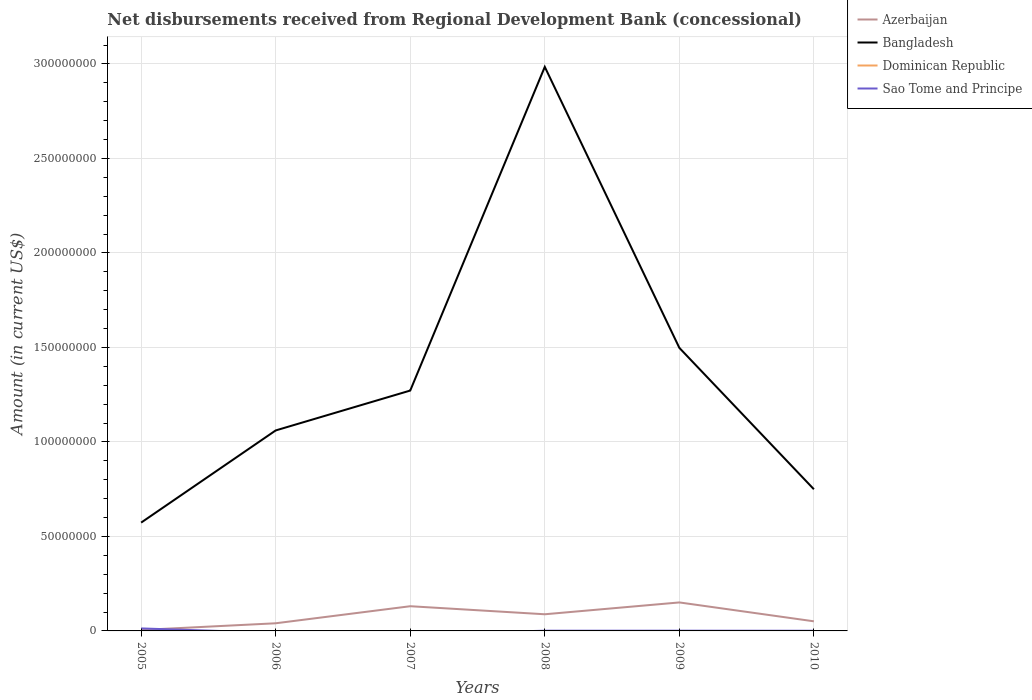Does the line corresponding to Dominican Republic intersect with the line corresponding to Azerbaijan?
Offer a very short reply. No. Is the number of lines equal to the number of legend labels?
Provide a short and direct response. No. What is the total amount of disbursements received from Regional Development Bank in Bangladesh in the graph?
Offer a terse response. -2.26e+07. What is the difference between the highest and the second highest amount of disbursements received from Regional Development Bank in Bangladesh?
Keep it short and to the point. 2.41e+08. What is the difference between the highest and the lowest amount of disbursements received from Regional Development Bank in Sao Tome and Principe?
Offer a terse response. 1. How many lines are there?
Your answer should be compact. 3. How many years are there in the graph?
Make the answer very short. 6. Are the values on the major ticks of Y-axis written in scientific E-notation?
Your answer should be very brief. No. Where does the legend appear in the graph?
Make the answer very short. Top right. How many legend labels are there?
Provide a succinct answer. 4. How are the legend labels stacked?
Give a very brief answer. Vertical. What is the title of the graph?
Make the answer very short. Net disbursements received from Regional Development Bank (concessional). Does "Singapore" appear as one of the legend labels in the graph?
Offer a very short reply. No. What is the label or title of the X-axis?
Your answer should be very brief. Years. What is the Amount (in current US$) in Azerbaijan in 2005?
Your answer should be very brief. 5.03e+05. What is the Amount (in current US$) in Bangladesh in 2005?
Your response must be concise. 5.73e+07. What is the Amount (in current US$) of Dominican Republic in 2005?
Ensure brevity in your answer.  0. What is the Amount (in current US$) of Sao Tome and Principe in 2005?
Provide a short and direct response. 1.32e+06. What is the Amount (in current US$) of Azerbaijan in 2006?
Provide a short and direct response. 4.04e+06. What is the Amount (in current US$) of Bangladesh in 2006?
Keep it short and to the point. 1.06e+08. What is the Amount (in current US$) of Dominican Republic in 2006?
Offer a terse response. 0. What is the Amount (in current US$) of Sao Tome and Principe in 2006?
Ensure brevity in your answer.  0. What is the Amount (in current US$) in Azerbaijan in 2007?
Give a very brief answer. 1.31e+07. What is the Amount (in current US$) of Bangladesh in 2007?
Provide a short and direct response. 1.27e+08. What is the Amount (in current US$) in Dominican Republic in 2007?
Keep it short and to the point. 0. What is the Amount (in current US$) in Azerbaijan in 2008?
Keep it short and to the point. 8.81e+06. What is the Amount (in current US$) of Bangladesh in 2008?
Your answer should be very brief. 2.98e+08. What is the Amount (in current US$) in Dominican Republic in 2008?
Your answer should be very brief. 0. What is the Amount (in current US$) in Sao Tome and Principe in 2008?
Provide a succinct answer. 1.18e+05. What is the Amount (in current US$) of Azerbaijan in 2009?
Ensure brevity in your answer.  1.51e+07. What is the Amount (in current US$) in Bangladesh in 2009?
Keep it short and to the point. 1.50e+08. What is the Amount (in current US$) in Dominican Republic in 2009?
Offer a terse response. 0. What is the Amount (in current US$) in Sao Tome and Principe in 2009?
Give a very brief answer. 1.20e+05. What is the Amount (in current US$) of Azerbaijan in 2010?
Make the answer very short. 5.08e+06. What is the Amount (in current US$) of Bangladesh in 2010?
Your answer should be very brief. 7.50e+07. What is the Amount (in current US$) in Dominican Republic in 2010?
Make the answer very short. 0. What is the Amount (in current US$) in Sao Tome and Principe in 2010?
Keep it short and to the point. 9.30e+04. Across all years, what is the maximum Amount (in current US$) of Azerbaijan?
Your answer should be very brief. 1.51e+07. Across all years, what is the maximum Amount (in current US$) of Bangladesh?
Ensure brevity in your answer.  2.98e+08. Across all years, what is the maximum Amount (in current US$) of Sao Tome and Principe?
Ensure brevity in your answer.  1.32e+06. Across all years, what is the minimum Amount (in current US$) in Azerbaijan?
Provide a short and direct response. 5.03e+05. Across all years, what is the minimum Amount (in current US$) of Bangladesh?
Provide a succinct answer. 5.73e+07. Across all years, what is the minimum Amount (in current US$) in Sao Tome and Principe?
Provide a short and direct response. 0. What is the total Amount (in current US$) of Azerbaijan in the graph?
Make the answer very short. 4.66e+07. What is the total Amount (in current US$) of Bangladesh in the graph?
Offer a very short reply. 8.14e+08. What is the total Amount (in current US$) of Sao Tome and Principe in the graph?
Keep it short and to the point. 1.65e+06. What is the difference between the Amount (in current US$) of Azerbaijan in 2005 and that in 2006?
Your response must be concise. -3.54e+06. What is the difference between the Amount (in current US$) of Bangladesh in 2005 and that in 2006?
Ensure brevity in your answer.  -4.88e+07. What is the difference between the Amount (in current US$) in Azerbaijan in 2005 and that in 2007?
Give a very brief answer. -1.26e+07. What is the difference between the Amount (in current US$) in Bangladesh in 2005 and that in 2007?
Your response must be concise. -6.99e+07. What is the difference between the Amount (in current US$) in Azerbaijan in 2005 and that in 2008?
Offer a terse response. -8.31e+06. What is the difference between the Amount (in current US$) in Bangladesh in 2005 and that in 2008?
Ensure brevity in your answer.  -2.41e+08. What is the difference between the Amount (in current US$) in Sao Tome and Principe in 2005 and that in 2008?
Make the answer very short. 1.20e+06. What is the difference between the Amount (in current US$) of Azerbaijan in 2005 and that in 2009?
Make the answer very short. -1.46e+07. What is the difference between the Amount (in current US$) in Bangladesh in 2005 and that in 2009?
Give a very brief answer. -9.25e+07. What is the difference between the Amount (in current US$) of Sao Tome and Principe in 2005 and that in 2009?
Keep it short and to the point. 1.20e+06. What is the difference between the Amount (in current US$) of Azerbaijan in 2005 and that in 2010?
Your answer should be compact. -4.58e+06. What is the difference between the Amount (in current US$) of Bangladesh in 2005 and that in 2010?
Offer a terse response. -1.76e+07. What is the difference between the Amount (in current US$) in Sao Tome and Principe in 2005 and that in 2010?
Make the answer very short. 1.23e+06. What is the difference between the Amount (in current US$) in Azerbaijan in 2006 and that in 2007?
Make the answer very short. -9.02e+06. What is the difference between the Amount (in current US$) of Bangladesh in 2006 and that in 2007?
Your answer should be compact. -2.11e+07. What is the difference between the Amount (in current US$) of Azerbaijan in 2006 and that in 2008?
Give a very brief answer. -4.77e+06. What is the difference between the Amount (in current US$) of Bangladesh in 2006 and that in 2008?
Your answer should be very brief. -1.92e+08. What is the difference between the Amount (in current US$) in Azerbaijan in 2006 and that in 2009?
Your answer should be compact. -1.10e+07. What is the difference between the Amount (in current US$) in Bangladesh in 2006 and that in 2009?
Your answer should be very brief. -4.37e+07. What is the difference between the Amount (in current US$) in Azerbaijan in 2006 and that in 2010?
Give a very brief answer. -1.04e+06. What is the difference between the Amount (in current US$) of Bangladesh in 2006 and that in 2010?
Offer a very short reply. 3.11e+07. What is the difference between the Amount (in current US$) of Azerbaijan in 2007 and that in 2008?
Provide a short and direct response. 4.26e+06. What is the difference between the Amount (in current US$) of Bangladesh in 2007 and that in 2008?
Offer a very short reply. -1.71e+08. What is the difference between the Amount (in current US$) in Azerbaijan in 2007 and that in 2009?
Keep it short and to the point. -2.00e+06. What is the difference between the Amount (in current US$) of Bangladesh in 2007 and that in 2009?
Your answer should be compact. -2.26e+07. What is the difference between the Amount (in current US$) in Azerbaijan in 2007 and that in 2010?
Offer a very short reply. 7.98e+06. What is the difference between the Amount (in current US$) of Bangladesh in 2007 and that in 2010?
Your answer should be compact. 5.22e+07. What is the difference between the Amount (in current US$) of Azerbaijan in 2008 and that in 2009?
Keep it short and to the point. -6.26e+06. What is the difference between the Amount (in current US$) of Bangladesh in 2008 and that in 2009?
Make the answer very short. 1.49e+08. What is the difference between the Amount (in current US$) in Sao Tome and Principe in 2008 and that in 2009?
Your answer should be compact. -2000. What is the difference between the Amount (in current US$) in Azerbaijan in 2008 and that in 2010?
Your response must be concise. 3.73e+06. What is the difference between the Amount (in current US$) in Bangladesh in 2008 and that in 2010?
Provide a short and direct response. 2.24e+08. What is the difference between the Amount (in current US$) of Sao Tome and Principe in 2008 and that in 2010?
Your response must be concise. 2.50e+04. What is the difference between the Amount (in current US$) in Azerbaijan in 2009 and that in 2010?
Ensure brevity in your answer.  9.99e+06. What is the difference between the Amount (in current US$) in Bangladesh in 2009 and that in 2010?
Give a very brief answer. 7.48e+07. What is the difference between the Amount (in current US$) of Sao Tome and Principe in 2009 and that in 2010?
Give a very brief answer. 2.70e+04. What is the difference between the Amount (in current US$) of Azerbaijan in 2005 and the Amount (in current US$) of Bangladesh in 2006?
Your response must be concise. -1.06e+08. What is the difference between the Amount (in current US$) of Azerbaijan in 2005 and the Amount (in current US$) of Bangladesh in 2007?
Make the answer very short. -1.27e+08. What is the difference between the Amount (in current US$) of Azerbaijan in 2005 and the Amount (in current US$) of Bangladesh in 2008?
Provide a succinct answer. -2.98e+08. What is the difference between the Amount (in current US$) in Azerbaijan in 2005 and the Amount (in current US$) in Sao Tome and Principe in 2008?
Offer a terse response. 3.85e+05. What is the difference between the Amount (in current US$) of Bangladesh in 2005 and the Amount (in current US$) of Sao Tome and Principe in 2008?
Give a very brief answer. 5.72e+07. What is the difference between the Amount (in current US$) of Azerbaijan in 2005 and the Amount (in current US$) of Bangladesh in 2009?
Provide a succinct answer. -1.49e+08. What is the difference between the Amount (in current US$) of Azerbaijan in 2005 and the Amount (in current US$) of Sao Tome and Principe in 2009?
Give a very brief answer. 3.83e+05. What is the difference between the Amount (in current US$) of Bangladesh in 2005 and the Amount (in current US$) of Sao Tome and Principe in 2009?
Provide a short and direct response. 5.72e+07. What is the difference between the Amount (in current US$) of Azerbaijan in 2005 and the Amount (in current US$) of Bangladesh in 2010?
Offer a terse response. -7.45e+07. What is the difference between the Amount (in current US$) in Azerbaijan in 2005 and the Amount (in current US$) in Sao Tome and Principe in 2010?
Ensure brevity in your answer.  4.10e+05. What is the difference between the Amount (in current US$) in Bangladesh in 2005 and the Amount (in current US$) in Sao Tome and Principe in 2010?
Your response must be concise. 5.72e+07. What is the difference between the Amount (in current US$) in Azerbaijan in 2006 and the Amount (in current US$) in Bangladesh in 2007?
Offer a very short reply. -1.23e+08. What is the difference between the Amount (in current US$) of Azerbaijan in 2006 and the Amount (in current US$) of Bangladesh in 2008?
Ensure brevity in your answer.  -2.94e+08. What is the difference between the Amount (in current US$) in Azerbaijan in 2006 and the Amount (in current US$) in Sao Tome and Principe in 2008?
Ensure brevity in your answer.  3.93e+06. What is the difference between the Amount (in current US$) of Bangladesh in 2006 and the Amount (in current US$) of Sao Tome and Principe in 2008?
Ensure brevity in your answer.  1.06e+08. What is the difference between the Amount (in current US$) in Azerbaijan in 2006 and the Amount (in current US$) in Bangladesh in 2009?
Your answer should be very brief. -1.46e+08. What is the difference between the Amount (in current US$) in Azerbaijan in 2006 and the Amount (in current US$) in Sao Tome and Principe in 2009?
Provide a short and direct response. 3.92e+06. What is the difference between the Amount (in current US$) of Bangladesh in 2006 and the Amount (in current US$) of Sao Tome and Principe in 2009?
Ensure brevity in your answer.  1.06e+08. What is the difference between the Amount (in current US$) in Azerbaijan in 2006 and the Amount (in current US$) in Bangladesh in 2010?
Provide a short and direct response. -7.09e+07. What is the difference between the Amount (in current US$) of Azerbaijan in 2006 and the Amount (in current US$) of Sao Tome and Principe in 2010?
Offer a very short reply. 3.95e+06. What is the difference between the Amount (in current US$) in Bangladesh in 2006 and the Amount (in current US$) in Sao Tome and Principe in 2010?
Make the answer very short. 1.06e+08. What is the difference between the Amount (in current US$) in Azerbaijan in 2007 and the Amount (in current US$) in Bangladesh in 2008?
Your answer should be compact. -2.85e+08. What is the difference between the Amount (in current US$) of Azerbaijan in 2007 and the Amount (in current US$) of Sao Tome and Principe in 2008?
Provide a succinct answer. 1.30e+07. What is the difference between the Amount (in current US$) of Bangladesh in 2007 and the Amount (in current US$) of Sao Tome and Principe in 2008?
Offer a very short reply. 1.27e+08. What is the difference between the Amount (in current US$) in Azerbaijan in 2007 and the Amount (in current US$) in Bangladesh in 2009?
Provide a short and direct response. -1.37e+08. What is the difference between the Amount (in current US$) of Azerbaijan in 2007 and the Amount (in current US$) of Sao Tome and Principe in 2009?
Your answer should be very brief. 1.30e+07. What is the difference between the Amount (in current US$) of Bangladesh in 2007 and the Amount (in current US$) of Sao Tome and Principe in 2009?
Provide a short and direct response. 1.27e+08. What is the difference between the Amount (in current US$) of Azerbaijan in 2007 and the Amount (in current US$) of Bangladesh in 2010?
Your response must be concise. -6.19e+07. What is the difference between the Amount (in current US$) of Azerbaijan in 2007 and the Amount (in current US$) of Sao Tome and Principe in 2010?
Ensure brevity in your answer.  1.30e+07. What is the difference between the Amount (in current US$) in Bangladesh in 2007 and the Amount (in current US$) in Sao Tome and Principe in 2010?
Provide a short and direct response. 1.27e+08. What is the difference between the Amount (in current US$) of Azerbaijan in 2008 and the Amount (in current US$) of Bangladesh in 2009?
Provide a succinct answer. -1.41e+08. What is the difference between the Amount (in current US$) in Azerbaijan in 2008 and the Amount (in current US$) in Sao Tome and Principe in 2009?
Provide a succinct answer. 8.69e+06. What is the difference between the Amount (in current US$) of Bangladesh in 2008 and the Amount (in current US$) of Sao Tome and Principe in 2009?
Your answer should be very brief. 2.98e+08. What is the difference between the Amount (in current US$) of Azerbaijan in 2008 and the Amount (in current US$) of Bangladesh in 2010?
Your answer should be compact. -6.62e+07. What is the difference between the Amount (in current US$) of Azerbaijan in 2008 and the Amount (in current US$) of Sao Tome and Principe in 2010?
Keep it short and to the point. 8.72e+06. What is the difference between the Amount (in current US$) of Bangladesh in 2008 and the Amount (in current US$) of Sao Tome and Principe in 2010?
Provide a short and direct response. 2.98e+08. What is the difference between the Amount (in current US$) of Azerbaijan in 2009 and the Amount (in current US$) of Bangladesh in 2010?
Your answer should be compact. -5.99e+07. What is the difference between the Amount (in current US$) in Azerbaijan in 2009 and the Amount (in current US$) in Sao Tome and Principe in 2010?
Give a very brief answer. 1.50e+07. What is the difference between the Amount (in current US$) of Bangladesh in 2009 and the Amount (in current US$) of Sao Tome and Principe in 2010?
Give a very brief answer. 1.50e+08. What is the average Amount (in current US$) in Azerbaijan per year?
Offer a terse response. 7.77e+06. What is the average Amount (in current US$) of Bangladesh per year?
Offer a very short reply. 1.36e+08. What is the average Amount (in current US$) in Sao Tome and Principe per year?
Offer a very short reply. 2.75e+05. In the year 2005, what is the difference between the Amount (in current US$) of Azerbaijan and Amount (in current US$) of Bangladesh?
Ensure brevity in your answer.  -5.68e+07. In the year 2005, what is the difference between the Amount (in current US$) of Azerbaijan and Amount (in current US$) of Sao Tome and Principe?
Your answer should be compact. -8.18e+05. In the year 2005, what is the difference between the Amount (in current US$) in Bangladesh and Amount (in current US$) in Sao Tome and Principe?
Provide a succinct answer. 5.60e+07. In the year 2006, what is the difference between the Amount (in current US$) in Azerbaijan and Amount (in current US$) in Bangladesh?
Make the answer very short. -1.02e+08. In the year 2007, what is the difference between the Amount (in current US$) of Azerbaijan and Amount (in current US$) of Bangladesh?
Ensure brevity in your answer.  -1.14e+08. In the year 2008, what is the difference between the Amount (in current US$) in Azerbaijan and Amount (in current US$) in Bangladesh?
Keep it short and to the point. -2.90e+08. In the year 2008, what is the difference between the Amount (in current US$) in Azerbaijan and Amount (in current US$) in Sao Tome and Principe?
Ensure brevity in your answer.  8.70e+06. In the year 2008, what is the difference between the Amount (in current US$) in Bangladesh and Amount (in current US$) in Sao Tome and Principe?
Your answer should be compact. 2.98e+08. In the year 2009, what is the difference between the Amount (in current US$) in Azerbaijan and Amount (in current US$) in Bangladesh?
Offer a very short reply. -1.35e+08. In the year 2009, what is the difference between the Amount (in current US$) of Azerbaijan and Amount (in current US$) of Sao Tome and Principe?
Your response must be concise. 1.50e+07. In the year 2009, what is the difference between the Amount (in current US$) of Bangladesh and Amount (in current US$) of Sao Tome and Principe?
Your response must be concise. 1.50e+08. In the year 2010, what is the difference between the Amount (in current US$) in Azerbaijan and Amount (in current US$) in Bangladesh?
Ensure brevity in your answer.  -6.99e+07. In the year 2010, what is the difference between the Amount (in current US$) in Azerbaijan and Amount (in current US$) in Sao Tome and Principe?
Provide a succinct answer. 4.99e+06. In the year 2010, what is the difference between the Amount (in current US$) of Bangladesh and Amount (in current US$) of Sao Tome and Principe?
Offer a very short reply. 7.49e+07. What is the ratio of the Amount (in current US$) of Azerbaijan in 2005 to that in 2006?
Offer a very short reply. 0.12. What is the ratio of the Amount (in current US$) in Bangladesh in 2005 to that in 2006?
Offer a very short reply. 0.54. What is the ratio of the Amount (in current US$) of Azerbaijan in 2005 to that in 2007?
Ensure brevity in your answer.  0.04. What is the ratio of the Amount (in current US$) of Bangladesh in 2005 to that in 2007?
Keep it short and to the point. 0.45. What is the ratio of the Amount (in current US$) of Azerbaijan in 2005 to that in 2008?
Your answer should be compact. 0.06. What is the ratio of the Amount (in current US$) of Bangladesh in 2005 to that in 2008?
Keep it short and to the point. 0.19. What is the ratio of the Amount (in current US$) of Sao Tome and Principe in 2005 to that in 2008?
Provide a short and direct response. 11.19. What is the ratio of the Amount (in current US$) of Azerbaijan in 2005 to that in 2009?
Provide a short and direct response. 0.03. What is the ratio of the Amount (in current US$) in Bangladesh in 2005 to that in 2009?
Provide a succinct answer. 0.38. What is the ratio of the Amount (in current US$) of Sao Tome and Principe in 2005 to that in 2009?
Offer a terse response. 11.01. What is the ratio of the Amount (in current US$) of Azerbaijan in 2005 to that in 2010?
Give a very brief answer. 0.1. What is the ratio of the Amount (in current US$) in Bangladesh in 2005 to that in 2010?
Provide a short and direct response. 0.76. What is the ratio of the Amount (in current US$) in Sao Tome and Principe in 2005 to that in 2010?
Ensure brevity in your answer.  14.2. What is the ratio of the Amount (in current US$) in Azerbaijan in 2006 to that in 2007?
Offer a very short reply. 0.31. What is the ratio of the Amount (in current US$) of Bangladesh in 2006 to that in 2007?
Your answer should be very brief. 0.83. What is the ratio of the Amount (in current US$) in Azerbaijan in 2006 to that in 2008?
Provide a succinct answer. 0.46. What is the ratio of the Amount (in current US$) of Bangladesh in 2006 to that in 2008?
Provide a short and direct response. 0.36. What is the ratio of the Amount (in current US$) of Azerbaijan in 2006 to that in 2009?
Ensure brevity in your answer.  0.27. What is the ratio of the Amount (in current US$) in Bangladesh in 2006 to that in 2009?
Provide a short and direct response. 0.71. What is the ratio of the Amount (in current US$) of Azerbaijan in 2006 to that in 2010?
Keep it short and to the point. 0.8. What is the ratio of the Amount (in current US$) in Bangladesh in 2006 to that in 2010?
Provide a short and direct response. 1.42. What is the ratio of the Amount (in current US$) of Azerbaijan in 2007 to that in 2008?
Give a very brief answer. 1.48. What is the ratio of the Amount (in current US$) of Bangladesh in 2007 to that in 2008?
Give a very brief answer. 0.43. What is the ratio of the Amount (in current US$) in Azerbaijan in 2007 to that in 2009?
Your response must be concise. 0.87. What is the ratio of the Amount (in current US$) in Bangladesh in 2007 to that in 2009?
Your answer should be compact. 0.85. What is the ratio of the Amount (in current US$) in Azerbaijan in 2007 to that in 2010?
Offer a terse response. 2.57. What is the ratio of the Amount (in current US$) of Bangladesh in 2007 to that in 2010?
Your answer should be very brief. 1.7. What is the ratio of the Amount (in current US$) of Azerbaijan in 2008 to that in 2009?
Offer a terse response. 0.58. What is the ratio of the Amount (in current US$) in Bangladesh in 2008 to that in 2009?
Give a very brief answer. 1.99. What is the ratio of the Amount (in current US$) in Sao Tome and Principe in 2008 to that in 2009?
Keep it short and to the point. 0.98. What is the ratio of the Amount (in current US$) in Azerbaijan in 2008 to that in 2010?
Your response must be concise. 1.73. What is the ratio of the Amount (in current US$) in Bangladesh in 2008 to that in 2010?
Offer a terse response. 3.98. What is the ratio of the Amount (in current US$) of Sao Tome and Principe in 2008 to that in 2010?
Ensure brevity in your answer.  1.27. What is the ratio of the Amount (in current US$) of Azerbaijan in 2009 to that in 2010?
Offer a terse response. 2.96. What is the ratio of the Amount (in current US$) in Bangladesh in 2009 to that in 2010?
Ensure brevity in your answer.  2. What is the ratio of the Amount (in current US$) in Sao Tome and Principe in 2009 to that in 2010?
Give a very brief answer. 1.29. What is the difference between the highest and the second highest Amount (in current US$) in Azerbaijan?
Make the answer very short. 2.00e+06. What is the difference between the highest and the second highest Amount (in current US$) of Bangladesh?
Provide a succinct answer. 1.49e+08. What is the difference between the highest and the second highest Amount (in current US$) of Sao Tome and Principe?
Your response must be concise. 1.20e+06. What is the difference between the highest and the lowest Amount (in current US$) of Azerbaijan?
Provide a succinct answer. 1.46e+07. What is the difference between the highest and the lowest Amount (in current US$) in Bangladesh?
Give a very brief answer. 2.41e+08. What is the difference between the highest and the lowest Amount (in current US$) in Sao Tome and Principe?
Your response must be concise. 1.32e+06. 